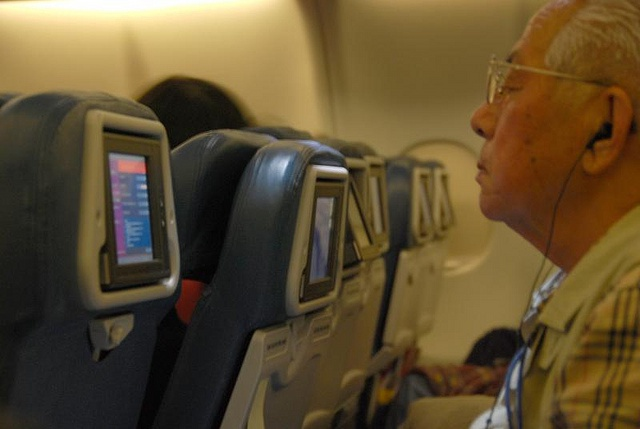Describe the objects in this image and their specific colors. I can see people in olive, maroon, and black tones, chair in olive, black, and gray tones, tv in olive, black, and gray tones, chair in olive and black tones, and tv in olive, black, and gray tones in this image. 